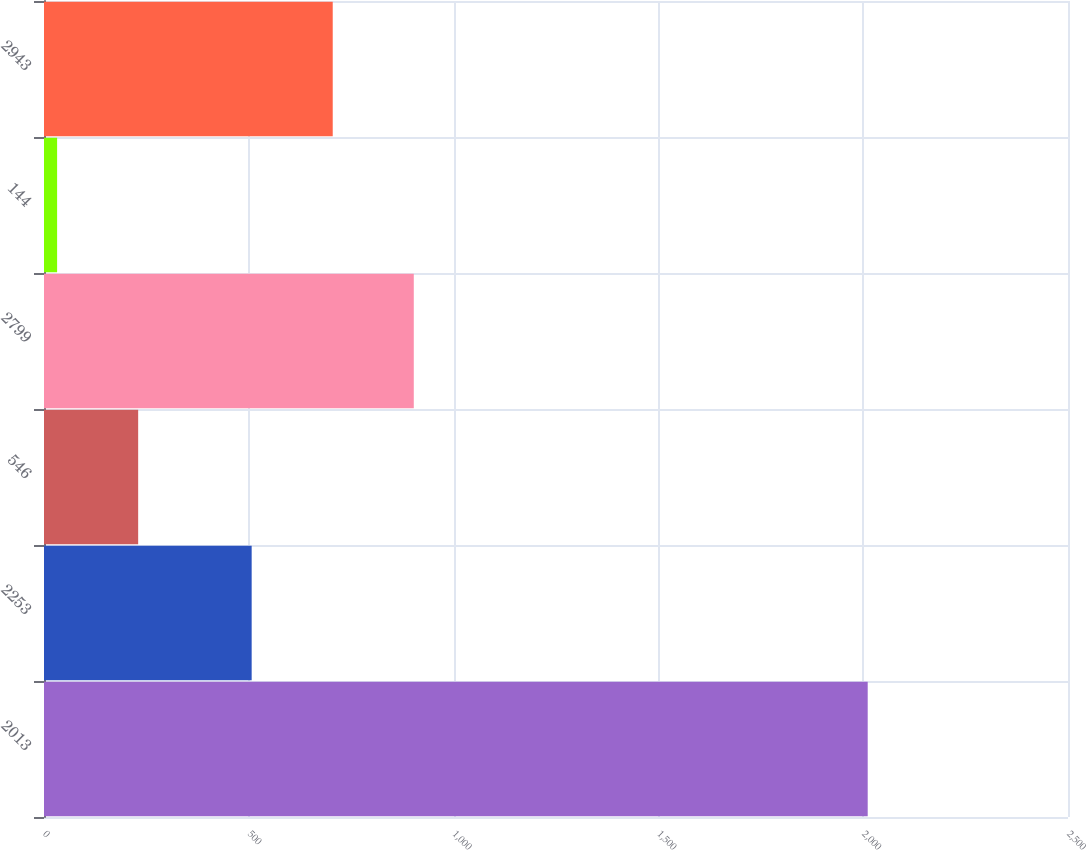Convert chart. <chart><loc_0><loc_0><loc_500><loc_500><bar_chart><fcel>2013<fcel>2253<fcel>546<fcel>2799<fcel>144<fcel>2943<nl><fcel>2011<fcel>507<fcel>229.9<fcel>902.8<fcel>32<fcel>704.9<nl></chart> 